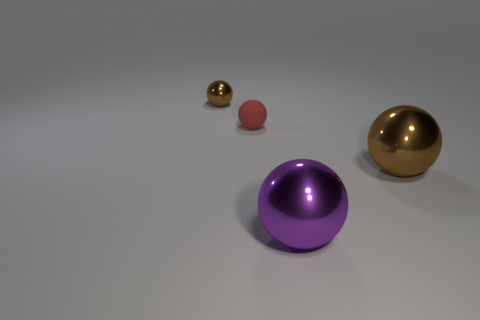Is there anything else that is made of the same material as the red thing?
Give a very brief answer. No. There is a ball that is the same color as the small metallic object; what is its material?
Keep it short and to the point. Metal. Is the number of large purple spheres that are in front of the matte thing less than the number of metal balls on the left side of the large brown shiny object?
Provide a short and direct response. Yes. How many other things are the same material as the red object?
Provide a succinct answer. 0. There is a large thing that is on the right side of the purple metal ball; is it the same color as the tiny metallic thing?
Make the answer very short. Yes. There is a metallic sphere that is to the left of the small red matte thing; is there a metallic ball on the right side of it?
Provide a succinct answer. Yes. There is a object that is in front of the small brown thing and behind the big brown thing; what is it made of?
Your answer should be compact. Rubber. What shape is the small object that is made of the same material as the purple ball?
Your answer should be very brief. Sphere. Are there any other things that are the same shape as the large purple object?
Give a very brief answer. Yes. Does the brown object that is right of the small brown metallic sphere have the same material as the red sphere?
Ensure brevity in your answer.  No. 